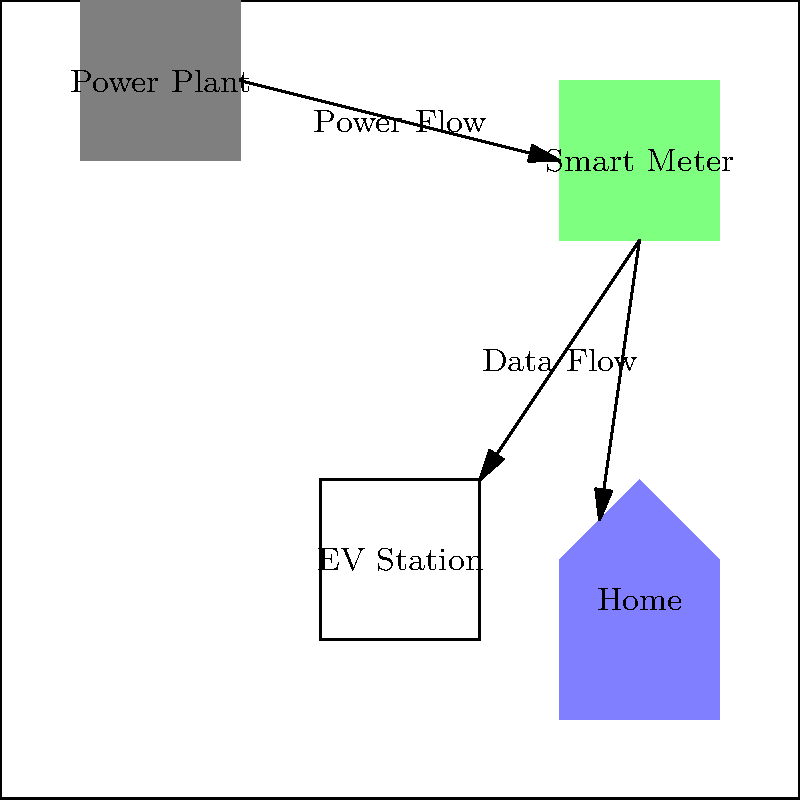In the smart grid integration diagram for optimizing electric vehicle charging times, which component serves as the central hub for managing power distribution and data communication between the power plant, EV charging station, and home? To answer this question, let's analyze the components and their relationships in the smart grid integration diagram:

1. Power Plant: This is the source of electricity generation, located at the top left of the diagram.

2. Smart Meter: Positioned in the center of the diagram, it receives power from the power plant and distributes it to both the EV charging station and the home.

3. EV Charging Station: Located at the bottom left, it receives power and data from the smart meter.

4. Home: Situated at the bottom right, it also receives power and data from the smart meter.

5. Arrows: They indicate the flow of power and data between components.

The smart meter is the central component in this diagram, acting as an intermediary between the power plant and the end-users (EV charging station and home). It manages power distribution and facilitates two-way communication of data, which is crucial for optimizing electric vehicle charging times.

The smart meter:
- Receives power from the power plant
- Distributes power to both the EV charging station and the home
- Collects and transmits data about power usage and demand
- Enables real-time monitoring and control of power consumption

This centralized management allows for efficient load balancing, dynamic pricing, and optimal scheduling of EV charging based on grid capacity and user preferences.
Answer: Smart Meter 